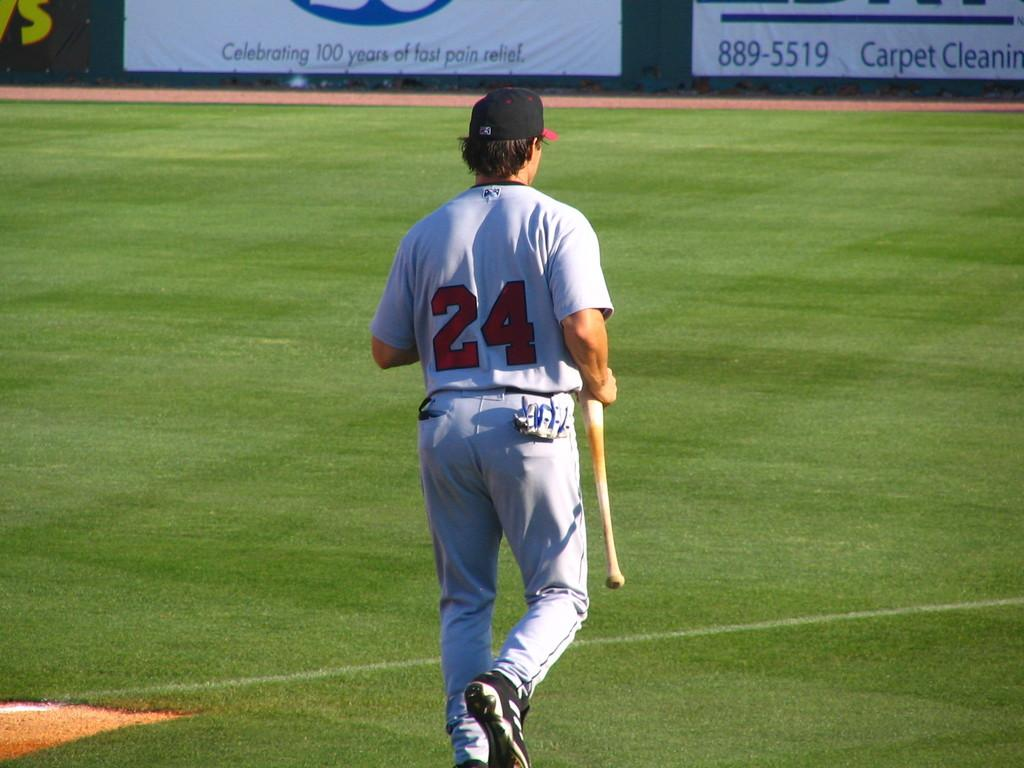<image>
Summarize the visual content of the image. player #24 walking with bat and sign on outfield wall visible showing phone number 889-5519 for carpet cleaning 